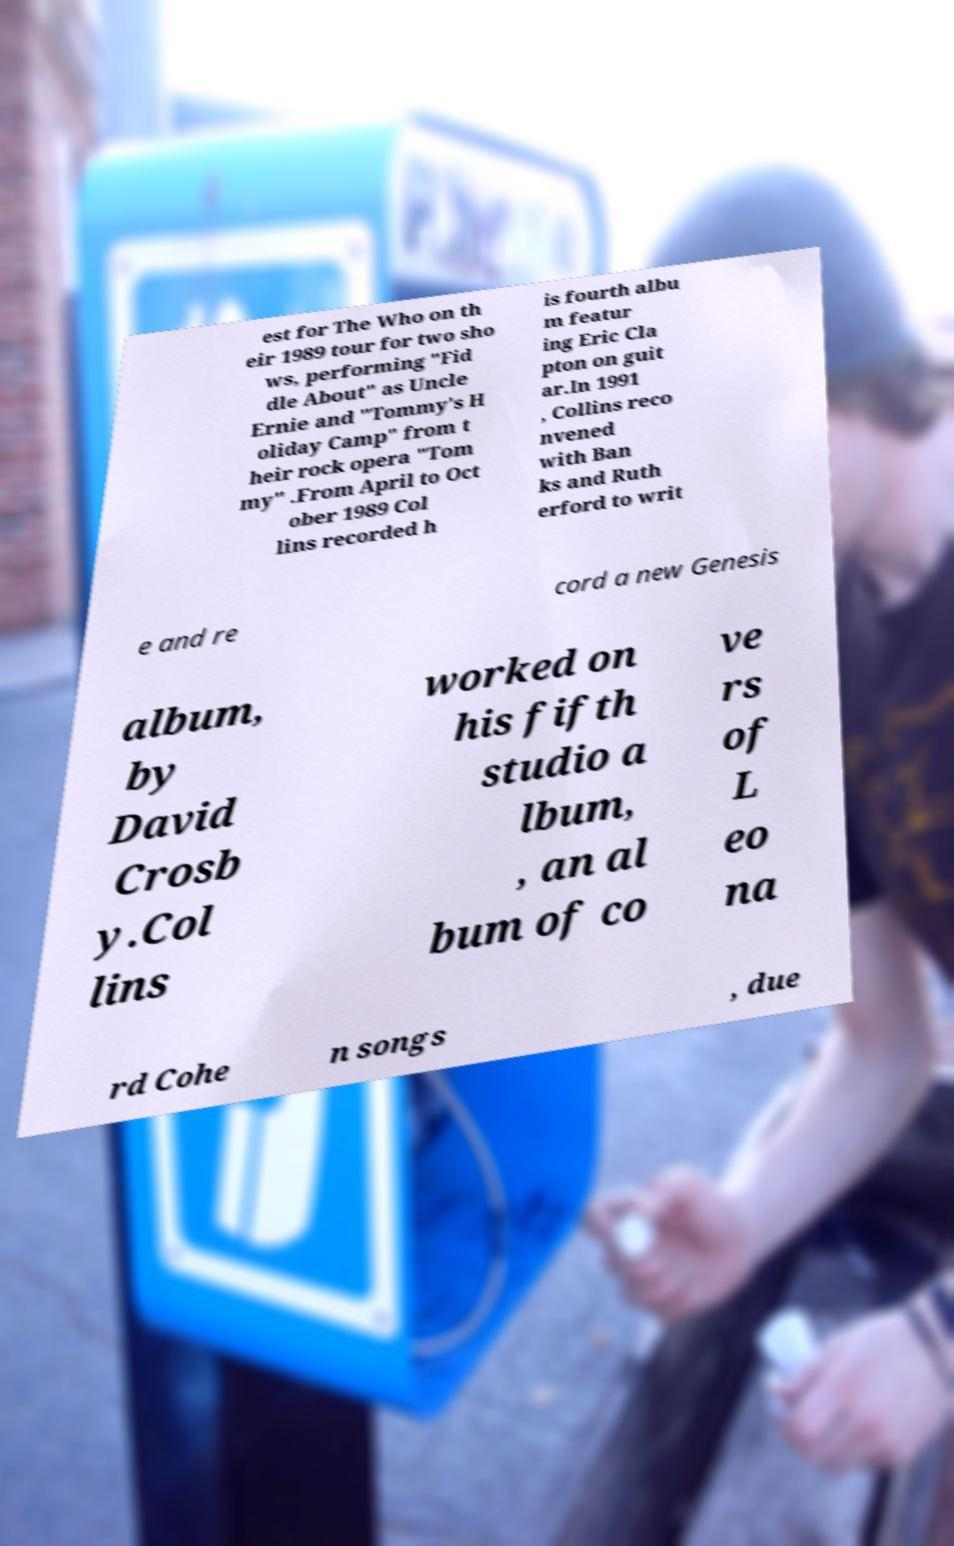I need the written content from this picture converted into text. Can you do that? est for The Who on th eir 1989 tour for two sho ws, performing "Fid dle About" as Uncle Ernie and "Tommy's H oliday Camp" from t heir rock opera "Tom my" .From April to Oct ober 1989 Col lins recorded h is fourth albu m featur ing Eric Cla pton on guit ar.In 1991 , Collins reco nvened with Ban ks and Ruth erford to writ e and re cord a new Genesis album, by David Crosb y.Col lins worked on his fifth studio a lbum, , an al bum of co ve rs of L eo na rd Cohe n songs , due 